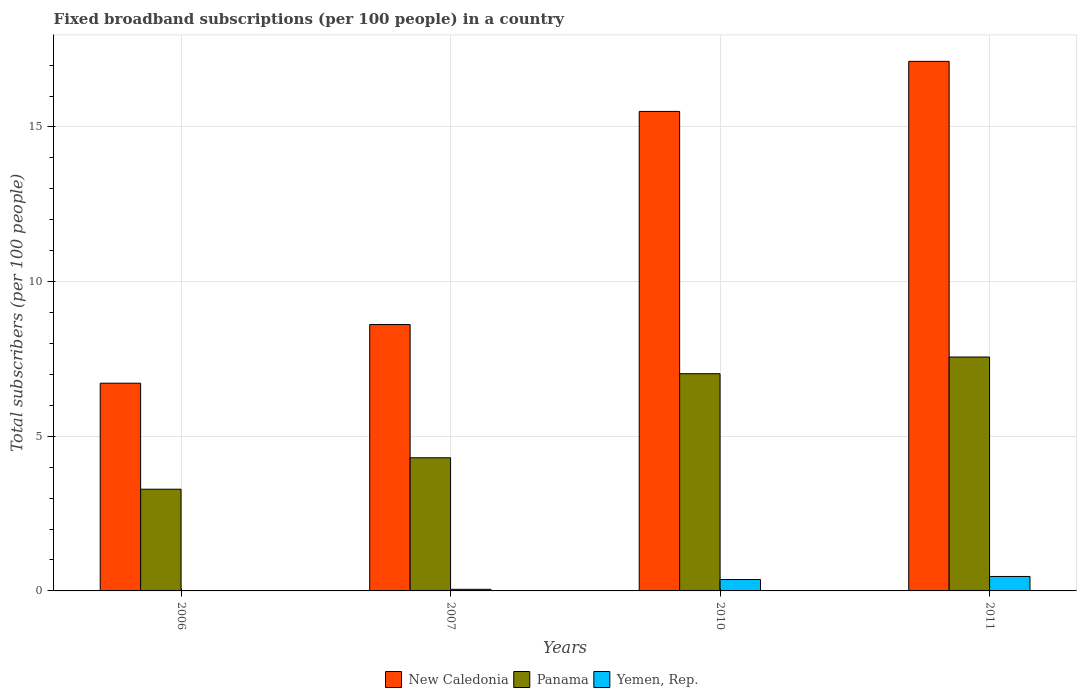How many different coloured bars are there?
Your answer should be compact. 3. How many groups of bars are there?
Provide a succinct answer. 4. Are the number of bars on each tick of the X-axis equal?
Provide a succinct answer. Yes. How many bars are there on the 3rd tick from the left?
Provide a short and direct response. 3. In how many cases, is the number of bars for a given year not equal to the number of legend labels?
Your answer should be very brief. 0. What is the number of broadband subscriptions in New Caledonia in 2011?
Your response must be concise. 17.12. Across all years, what is the maximum number of broadband subscriptions in Yemen, Rep.?
Your answer should be compact. 0.47. Across all years, what is the minimum number of broadband subscriptions in Yemen, Rep.?
Provide a succinct answer. 0.01. In which year was the number of broadband subscriptions in Yemen, Rep. minimum?
Provide a short and direct response. 2006. What is the total number of broadband subscriptions in New Caledonia in the graph?
Ensure brevity in your answer.  47.95. What is the difference between the number of broadband subscriptions in Yemen, Rep. in 2006 and that in 2010?
Offer a terse response. -0.36. What is the difference between the number of broadband subscriptions in Panama in 2011 and the number of broadband subscriptions in New Caledonia in 2010?
Your answer should be compact. -7.94. What is the average number of broadband subscriptions in New Caledonia per year?
Keep it short and to the point. 11.99. In the year 2007, what is the difference between the number of broadband subscriptions in Panama and number of broadband subscriptions in Yemen, Rep.?
Offer a terse response. 4.25. What is the ratio of the number of broadband subscriptions in New Caledonia in 2007 to that in 2011?
Make the answer very short. 0.5. Is the number of broadband subscriptions in Yemen, Rep. in 2006 less than that in 2011?
Your response must be concise. Yes. What is the difference between the highest and the second highest number of broadband subscriptions in Yemen, Rep.?
Your answer should be compact. 0.1. What is the difference between the highest and the lowest number of broadband subscriptions in Panama?
Your answer should be compact. 4.27. In how many years, is the number of broadband subscriptions in Yemen, Rep. greater than the average number of broadband subscriptions in Yemen, Rep. taken over all years?
Provide a short and direct response. 2. What does the 1st bar from the left in 2010 represents?
Offer a terse response. New Caledonia. What does the 2nd bar from the right in 2007 represents?
Your answer should be compact. Panama. How many bars are there?
Your response must be concise. 12. Are all the bars in the graph horizontal?
Offer a terse response. No. How many years are there in the graph?
Provide a succinct answer. 4. What is the difference between two consecutive major ticks on the Y-axis?
Keep it short and to the point. 5. Are the values on the major ticks of Y-axis written in scientific E-notation?
Offer a very short reply. No. Does the graph contain any zero values?
Offer a terse response. No. Does the graph contain grids?
Your answer should be compact. Yes. Where does the legend appear in the graph?
Provide a short and direct response. Bottom center. How many legend labels are there?
Ensure brevity in your answer.  3. How are the legend labels stacked?
Your response must be concise. Horizontal. What is the title of the graph?
Offer a very short reply. Fixed broadband subscriptions (per 100 people) in a country. Does "Morocco" appear as one of the legend labels in the graph?
Make the answer very short. No. What is the label or title of the Y-axis?
Provide a succinct answer. Total subscribers (per 100 people). What is the Total subscribers (per 100 people) in New Caledonia in 2006?
Provide a short and direct response. 6.72. What is the Total subscribers (per 100 people) of Panama in 2006?
Offer a very short reply. 3.29. What is the Total subscribers (per 100 people) of Yemen, Rep. in 2006?
Offer a very short reply. 0.01. What is the Total subscribers (per 100 people) of New Caledonia in 2007?
Make the answer very short. 8.61. What is the Total subscribers (per 100 people) of Panama in 2007?
Make the answer very short. 4.3. What is the Total subscribers (per 100 people) in Yemen, Rep. in 2007?
Your response must be concise. 0.05. What is the Total subscribers (per 100 people) of New Caledonia in 2010?
Give a very brief answer. 15.5. What is the Total subscribers (per 100 people) of Panama in 2010?
Your response must be concise. 7.02. What is the Total subscribers (per 100 people) in Yemen, Rep. in 2010?
Your answer should be compact. 0.37. What is the Total subscribers (per 100 people) in New Caledonia in 2011?
Offer a terse response. 17.12. What is the Total subscribers (per 100 people) of Panama in 2011?
Your answer should be compact. 7.56. What is the Total subscribers (per 100 people) of Yemen, Rep. in 2011?
Provide a short and direct response. 0.47. Across all years, what is the maximum Total subscribers (per 100 people) of New Caledonia?
Ensure brevity in your answer.  17.12. Across all years, what is the maximum Total subscribers (per 100 people) in Panama?
Your answer should be very brief. 7.56. Across all years, what is the maximum Total subscribers (per 100 people) of Yemen, Rep.?
Your response must be concise. 0.47. Across all years, what is the minimum Total subscribers (per 100 people) in New Caledonia?
Your answer should be compact. 6.72. Across all years, what is the minimum Total subscribers (per 100 people) of Panama?
Provide a short and direct response. 3.29. Across all years, what is the minimum Total subscribers (per 100 people) of Yemen, Rep.?
Give a very brief answer. 0.01. What is the total Total subscribers (per 100 people) in New Caledonia in the graph?
Provide a short and direct response. 47.95. What is the total Total subscribers (per 100 people) in Panama in the graph?
Your answer should be compact. 22.18. What is the total Total subscribers (per 100 people) of Yemen, Rep. in the graph?
Keep it short and to the point. 0.9. What is the difference between the Total subscribers (per 100 people) in New Caledonia in 2006 and that in 2007?
Your answer should be very brief. -1.9. What is the difference between the Total subscribers (per 100 people) in Panama in 2006 and that in 2007?
Provide a short and direct response. -1.02. What is the difference between the Total subscribers (per 100 people) in Yemen, Rep. in 2006 and that in 2007?
Offer a terse response. -0.04. What is the difference between the Total subscribers (per 100 people) of New Caledonia in 2006 and that in 2010?
Make the answer very short. -8.79. What is the difference between the Total subscribers (per 100 people) in Panama in 2006 and that in 2010?
Your response must be concise. -3.73. What is the difference between the Total subscribers (per 100 people) of Yemen, Rep. in 2006 and that in 2010?
Your answer should be very brief. -0.36. What is the difference between the Total subscribers (per 100 people) in New Caledonia in 2006 and that in 2011?
Keep it short and to the point. -10.41. What is the difference between the Total subscribers (per 100 people) of Panama in 2006 and that in 2011?
Give a very brief answer. -4.27. What is the difference between the Total subscribers (per 100 people) in Yemen, Rep. in 2006 and that in 2011?
Your answer should be very brief. -0.45. What is the difference between the Total subscribers (per 100 people) of New Caledonia in 2007 and that in 2010?
Your answer should be very brief. -6.89. What is the difference between the Total subscribers (per 100 people) in Panama in 2007 and that in 2010?
Offer a terse response. -2.72. What is the difference between the Total subscribers (per 100 people) in Yemen, Rep. in 2007 and that in 2010?
Make the answer very short. -0.32. What is the difference between the Total subscribers (per 100 people) in New Caledonia in 2007 and that in 2011?
Ensure brevity in your answer.  -8.51. What is the difference between the Total subscribers (per 100 people) in Panama in 2007 and that in 2011?
Offer a very short reply. -3.26. What is the difference between the Total subscribers (per 100 people) of Yemen, Rep. in 2007 and that in 2011?
Make the answer very short. -0.42. What is the difference between the Total subscribers (per 100 people) in New Caledonia in 2010 and that in 2011?
Provide a short and direct response. -1.62. What is the difference between the Total subscribers (per 100 people) of Panama in 2010 and that in 2011?
Your answer should be compact. -0.54. What is the difference between the Total subscribers (per 100 people) of Yemen, Rep. in 2010 and that in 2011?
Make the answer very short. -0.1. What is the difference between the Total subscribers (per 100 people) in New Caledonia in 2006 and the Total subscribers (per 100 people) in Panama in 2007?
Give a very brief answer. 2.41. What is the difference between the Total subscribers (per 100 people) in New Caledonia in 2006 and the Total subscribers (per 100 people) in Yemen, Rep. in 2007?
Offer a very short reply. 6.66. What is the difference between the Total subscribers (per 100 people) of Panama in 2006 and the Total subscribers (per 100 people) of Yemen, Rep. in 2007?
Give a very brief answer. 3.24. What is the difference between the Total subscribers (per 100 people) of New Caledonia in 2006 and the Total subscribers (per 100 people) of Panama in 2010?
Your answer should be very brief. -0.31. What is the difference between the Total subscribers (per 100 people) in New Caledonia in 2006 and the Total subscribers (per 100 people) in Yemen, Rep. in 2010?
Your answer should be very brief. 6.35. What is the difference between the Total subscribers (per 100 people) of Panama in 2006 and the Total subscribers (per 100 people) of Yemen, Rep. in 2010?
Give a very brief answer. 2.92. What is the difference between the Total subscribers (per 100 people) of New Caledonia in 2006 and the Total subscribers (per 100 people) of Panama in 2011?
Your answer should be very brief. -0.85. What is the difference between the Total subscribers (per 100 people) of New Caledonia in 2006 and the Total subscribers (per 100 people) of Yemen, Rep. in 2011?
Your response must be concise. 6.25. What is the difference between the Total subscribers (per 100 people) in Panama in 2006 and the Total subscribers (per 100 people) in Yemen, Rep. in 2011?
Offer a very short reply. 2.82. What is the difference between the Total subscribers (per 100 people) in New Caledonia in 2007 and the Total subscribers (per 100 people) in Panama in 2010?
Provide a succinct answer. 1.59. What is the difference between the Total subscribers (per 100 people) of New Caledonia in 2007 and the Total subscribers (per 100 people) of Yemen, Rep. in 2010?
Your answer should be compact. 8.24. What is the difference between the Total subscribers (per 100 people) in Panama in 2007 and the Total subscribers (per 100 people) in Yemen, Rep. in 2010?
Your response must be concise. 3.94. What is the difference between the Total subscribers (per 100 people) in New Caledonia in 2007 and the Total subscribers (per 100 people) in Panama in 2011?
Offer a terse response. 1.05. What is the difference between the Total subscribers (per 100 people) in New Caledonia in 2007 and the Total subscribers (per 100 people) in Yemen, Rep. in 2011?
Offer a terse response. 8.14. What is the difference between the Total subscribers (per 100 people) of Panama in 2007 and the Total subscribers (per 100 people) of Yemen, Rep. in 2011?
Give a very brief answer. 3.84. What is the difference between the Total subscribers (per 100 people) of New Caledonia in 2010 and the Total subscribers (per 100 people) of Panama in 2011?
Offer a very short reply. 7.94. What is the difference between the Total subscribers (per 100 people) of New Caledonia in 2010 and the Total subscribers (per 100 people) of Yemen, Rep. in 2011?
Provide a succinct answer. 15.04. What is the difference between the Total subscribers (per 100 people) in Panama in 2010 and the Total subscribers (per 100 people) in Yemen, Rep. in 2011?
Provide a short and direct response. 6.55. What is the average Total subscribers (per 100 people) in New Caledonia per year?
Your response must be concise. 11.99. What is the average Total subscribers (per 100 people) of Panama per year?
Keep it short and to the point. 5.54. What is the average Total subscribers (per 100 people) of Yemen, Rep. per year?
Offer a terse response. 0.23. In the year 2006, what is the difference between the Total subscribers (per 100 people) in New Caledonia and Total subscribers (per 100 people) in Panama?
Make the answer very short. 3.43. In the year 2006, what is the difference between the Total subscribers (per 100 people) in New Caledonia and Total subscribers (per 100 people) in Yemen, Rep.?
Offer a terse response. 6.7. In the year 2006, what is the difference between the Total subscribers (per 100 people) of Panama and Total subscribers (per 100 people) of Yemen, Rep.?
Your response must be concise. 3.27. In the year 2007, what is the difference between the Total subscribers (per 100 people) of New Caledonia and Total subscribers (per 100 people) of Panama?
Offer a very short reply. 4.31. In the year 2007, what is the difference between the Total subscribers (per 100 people) of New Caledonia and Total subscribers (per 100 people) of Yemen, Rep.?
Provide a short and direct response. 8.56. In the year 2007, what is the difference between the Total subscribers (per 100 people) in Panama and Total subscribers (per 100 people) in Yemen, Rep.?
Offer a terse response. 4.25. In the year 2010, what is the difference between the Total subscribers (per 100 people) in New Caledonia and Total subscribers (per 100 people) in Panama?
Keep it short and to the point. 8.48. In the year 2010, what is the difference between the Total subscribers (per 100 people) in New Caledonia and Total subscribers (per 100 people) in Yemen, Rep.?
Make the answer very short. 15.13. In the year 2010, what is the difference between the Total subscribers (per 100 people) in Panama and Total subscribers (per 100 people) in Yemen, Rep.?
Give a very brief answer. 6.65. In the year 2011, what is the difference between the Total subscribers (per 100 people) in New Caledonia and Total subscribers (per 100 people) in Panama?
Offer a terse response. 9.56. In the year 2011, what is the difference between the Total subscribers (per 100 people) in New Caledonia and Total subscribers (per 100 people) in Yemen, Rep.?
Your answer should be very brief. 16.65. In the year 2011, what is the difference between the Total subscribers (per 100 people) of Panama and Total subscribers (per 100 people) of Yemen, Rep.?
Offer a very short reply. 7.09. What is the ratio of the Total subscribers (per 100 people) in New Caledonia in 2006 to that in 2007?
Offer a terse response. 0.78. What is the ratio of the Total subscribers (per 100 people) of Panama in 2006 to that in 2007?
Your answer should be very brief. 0.76. What is the ratio of the Total subscribers (per 100 people) of Yemen, Rep. in 2006 to that in 2007?
Keep it short and to the point. 0.26. What is the ratio of the Total subscribers (per 100 people) of New Caledonia in 2006 to that in 2010?
Give a very brief answer. 0.43. What is the ratio of the Total subscribers (per 100 people) of Panama in 2006 to that in 2010?
Your answer should be very brief. 0.47. What is the ratio of the Total subscribers (per 100 people) of Yemen, Rep. in 2006 to that in 2010?
Your answer should be very brief. 0.04. What is the ratio of the Total subscribers (per 100 people) in New Caledonia in 2006 to that in 2011?
Ensure brevity in your answer.  0.39. What is the ratio of the Total subscribers (per 100 people) of Panama in 2006 to that in 2011?
Provide a succinct answer. 0.43. What is the ratio of the Total subscribers (per 100 people) in Yemen, Rep. in 2006 to that in 2011?
Offer a very short reply. 0.03. What is the ratio of the Total subscribers (per 100 people) in New Caledonia in 2007 to that in 2010?
Your answer should be compact. 0.56. What is the ratio of the Total subscribers (per 100 people) in Panama in 2007 to that in 2010?
Your answer should be compact. 0.61. What is the ratio of the Total subscribers (per 100 people) of Yemen, Rep. in 2007 to that in 2010?
Your response must be concise. 0.14. What is the ratio of the Total subscribers (per 100 people) in New Caledonia in 2007 to that in 2011?
Keep it short and to the point. 0.5. What is the ratio of the Total subscribers (per 100 people) in Panama in 2007 to that in 2011?
Make the answer very short. 0.57. What is the ratio of the Total subscribers (per 100 people) of Yemen, Rep. in 2007 to that in 2011?
Provide a succinct answer. 0.11. What is the ratio of the Total subscribers (per 100 people) of New Caledonia in 2010 to that in 2011?
Give a very brief answer. 0.91. What is the ratio of the Total subscribers (per 100 people) in Yemen, Rep. in 2010 to that in 2011?
Keep it short and to the point. 0.79. What is the difference between the highest and the second highest Total subscribers (per 100 people) in New Caledonia?
Your answer should be very brief. 1.62. What is the difference between the highest and the second highest Total subscribers (per 100 people) in Panama?
Ensure brevity in your answer.  0.54. What is the difference between the highest and the second highest Total subscribers (per 100 people) of Yemen, Rep.?
Provide a short and direct response. 0.1. What is the difference between the highest and the lowest Total subscribers (per 100 people) of New Caledonia?
Offer a terse response. 10.41. What is the difference between the highest and the lowest Total subscribers (per 100 people) in Panama?
Provide a succinct answer. 4.27. What is the difference between the highest and the lowest Total subscribers (per 100 people) of Yemen, Rep.?
Provide a succinct answer. 0.45. 